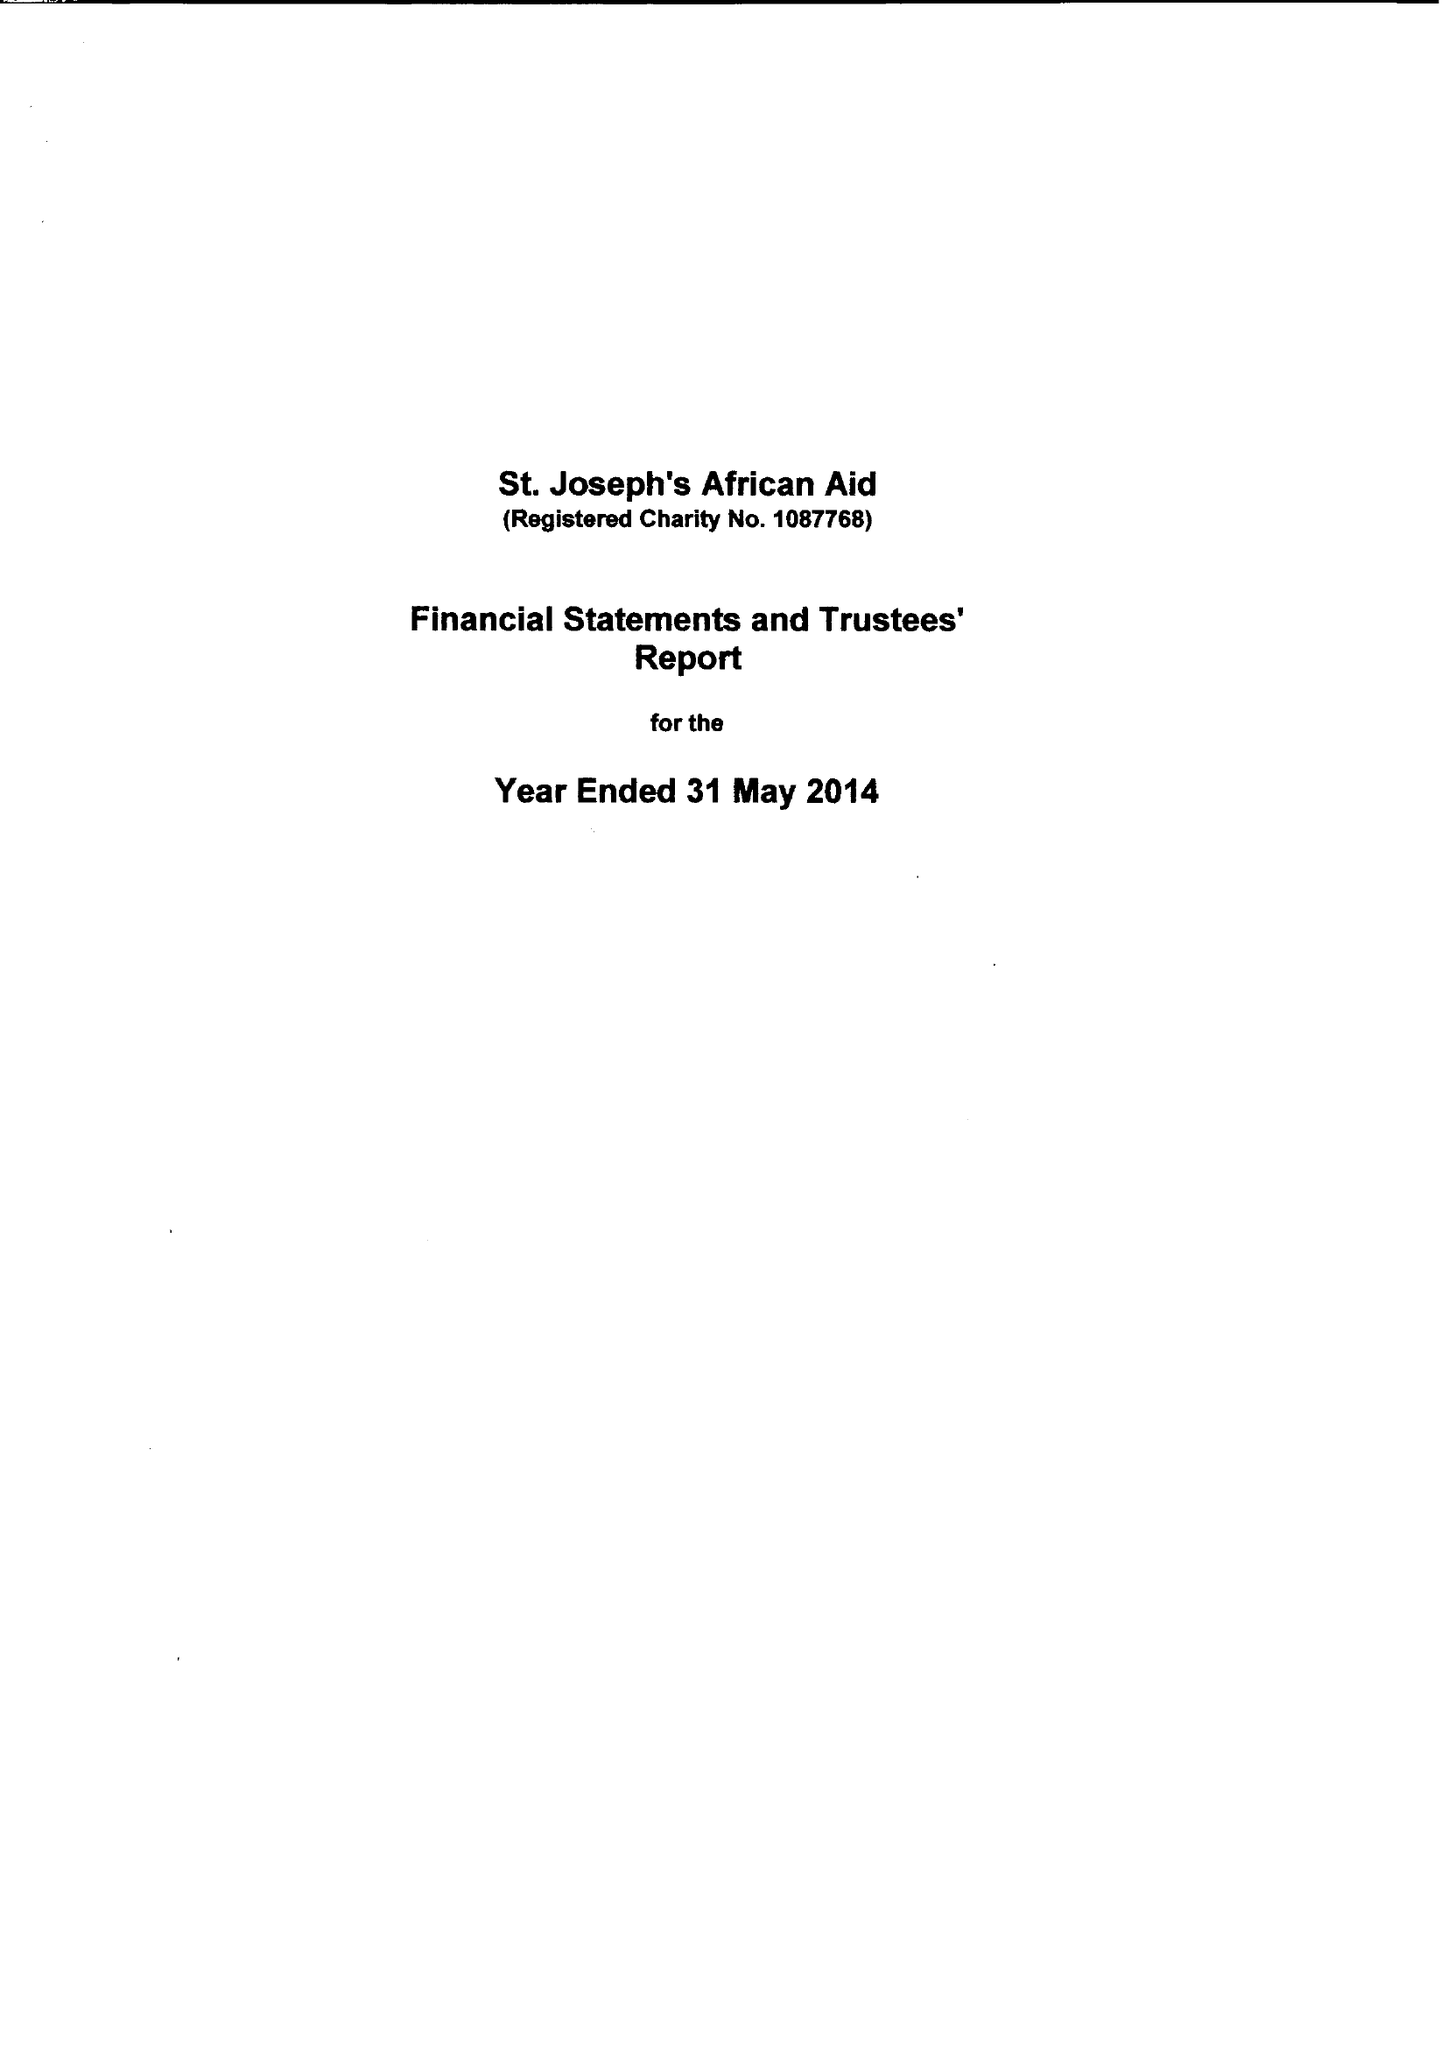What is the value for the spending_annually_in_british_pounds?
Answer the question using a single word or phrase. 25500.00 